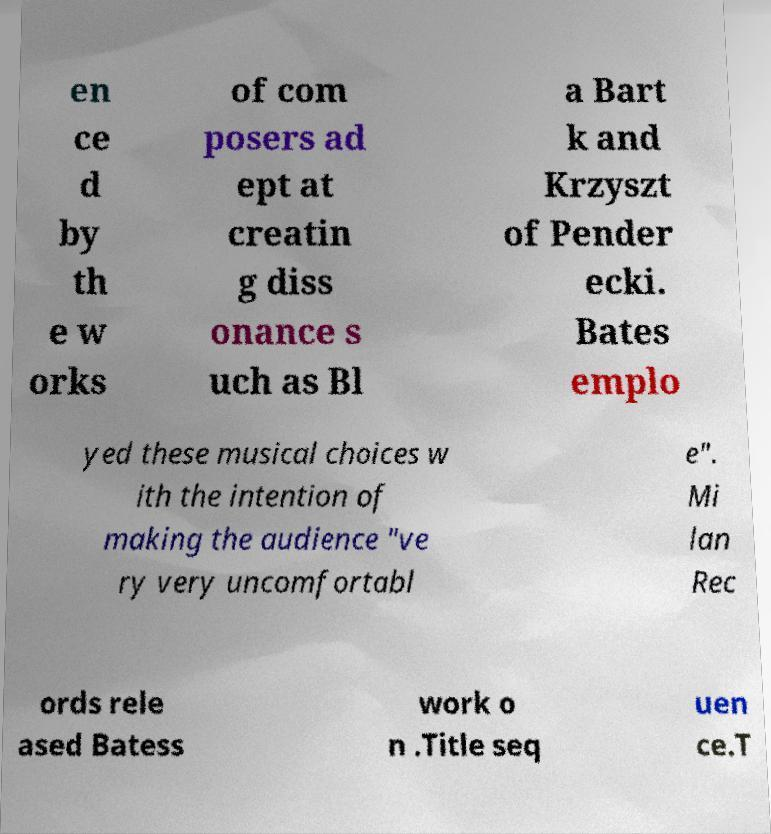For documentation purposes, I need the text within this image transcribed. Could you provide that? en ce d by th e w orks of com posers ad ept at creatin g diss onance s uch as Bl a Bart k and Krzyszt of Pender ecki. Bates emplo yed these musical choices w ith the intention of making the audience "ve ry very uncomfortabl e". Mi lan Rec ords rele ased Batess work o n .Title seq uen ce.T 